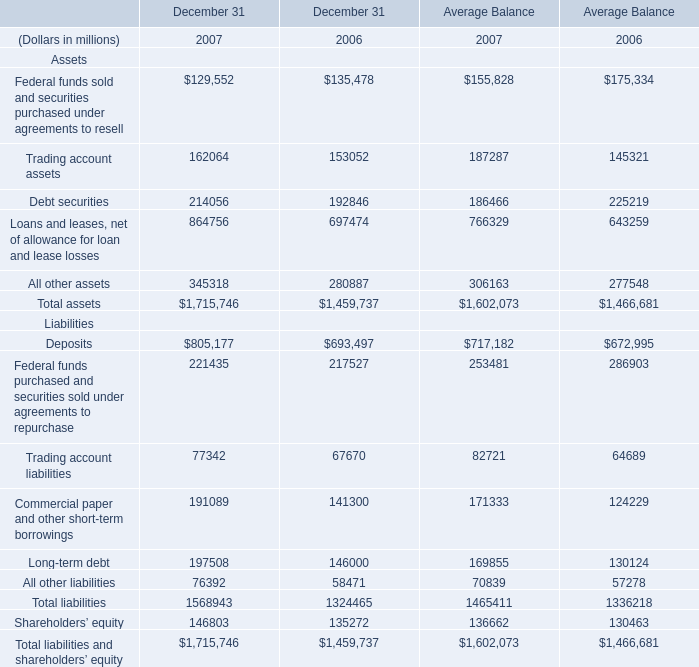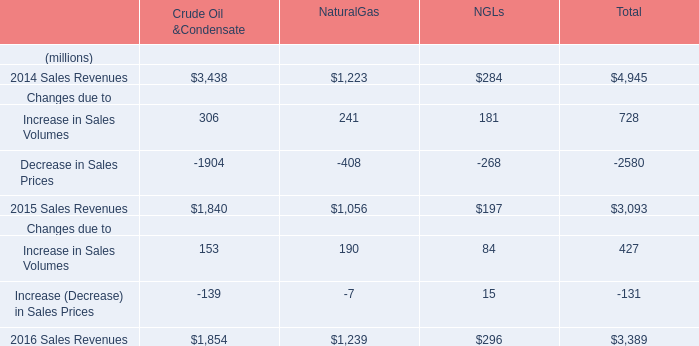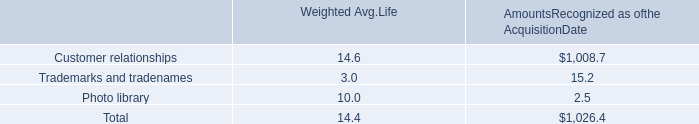What is the sum of Deposits Liabilities of Average Balance 2007, Customer relationships of AmountsRecognized as ofthe AcquisitionDate, and 2016 Sales Revenues Changes due to of Total ? 
Computations: ((717182.0 + 1008.7) + 3389.0)
Answer: 721579.7. 